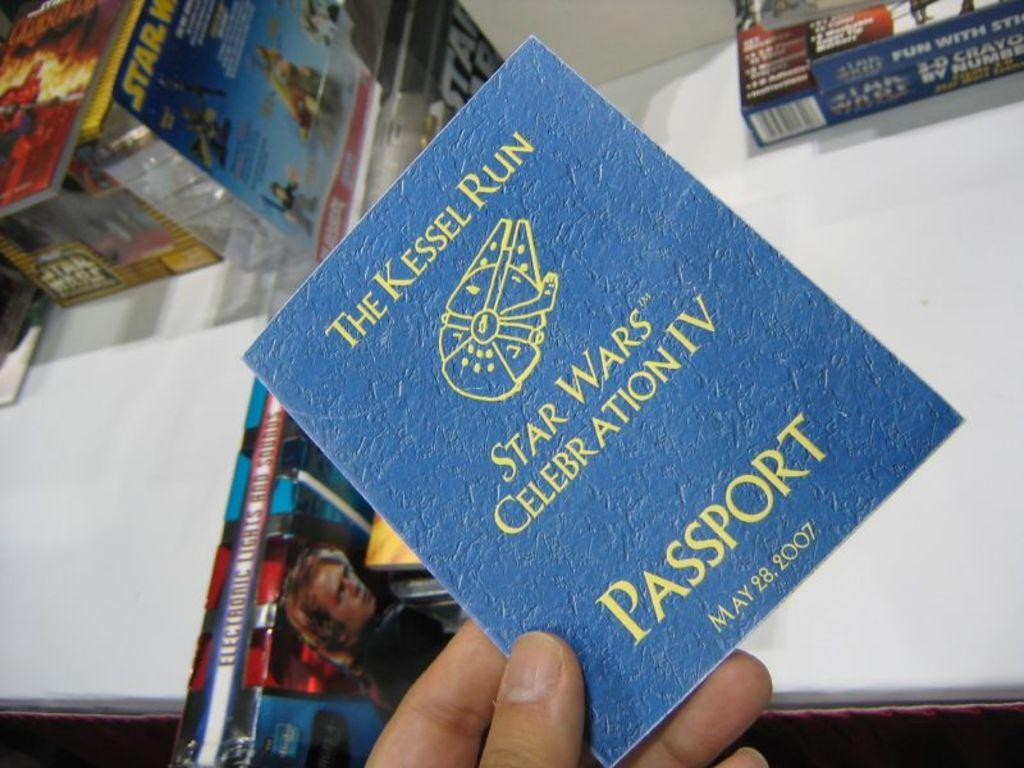<image>
Provide a brief description of the given image. a passport that says 'the kessel run star wars celebration iv' on it 